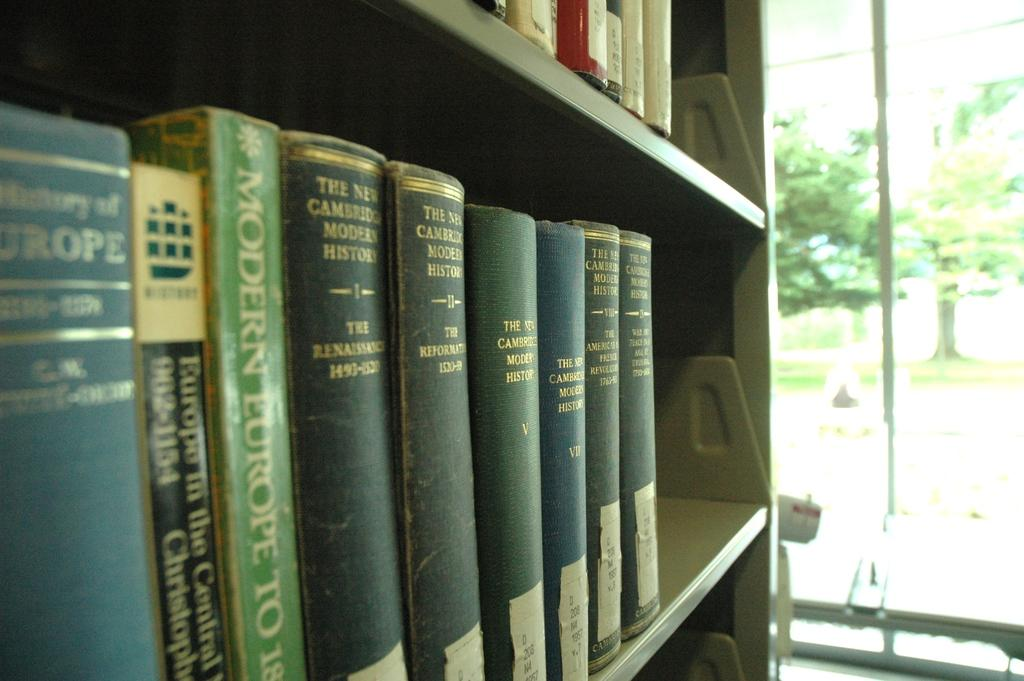<image>
Summarize the visual content of the image. Green books on a shelf with one that says MODERN EUROPE. 